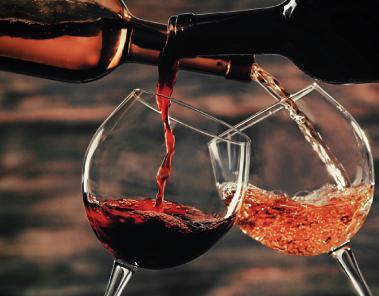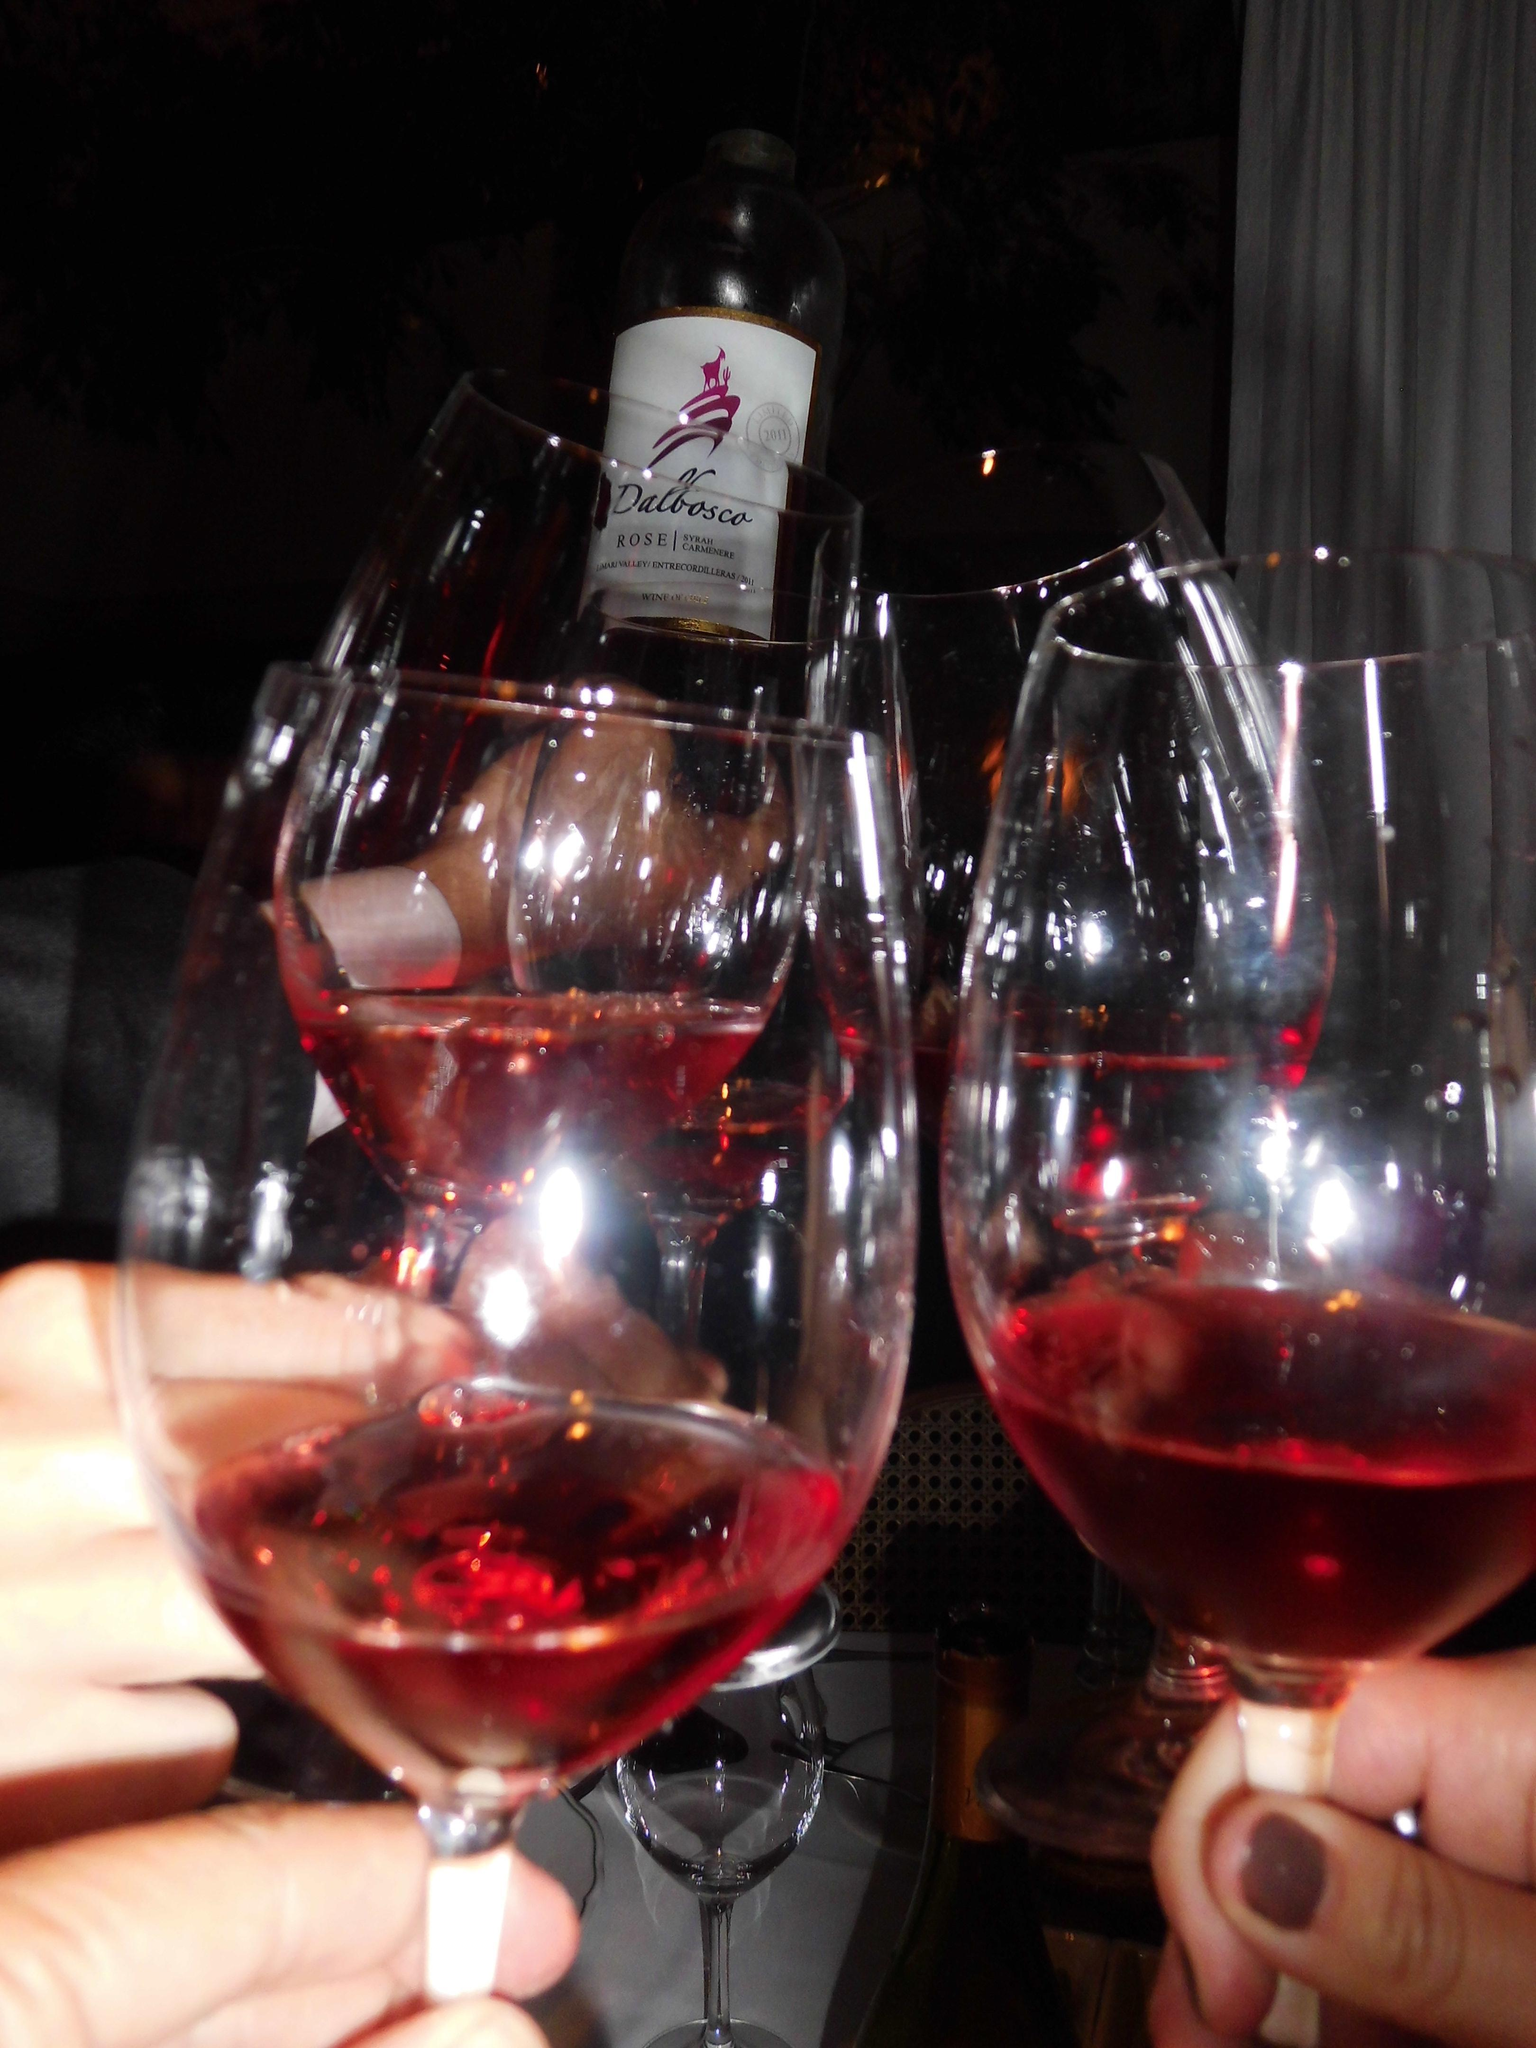The first image is the image on the left, the second image is the image on the right. For the images shown, is this caption "Exactly one image shows hands holding stemmed glasses of wine." true? Answer yes or no. Yes. 